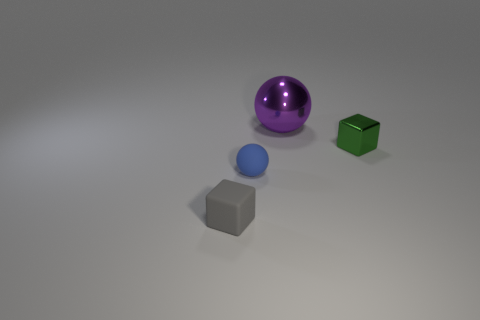What is the color of the tiny rubber thing left of the tiny rubber object to the right of the cube that is to the left of the blue sphere?
Your answer should be very brief. Gray. Is there any other thing that has the same material as the purple ball?
Provide a succinct answer. Yes. What is the size of the purple metallic object that is the same shape as the small blue thing?
Give a very brief answer. Large. Is the number of green objects that are to the left of the big purple shiny object less than the number of tiny cubes on the left side of the metal block?
Give a very brief answer. Yes. There is a thing that is both to the right of the blue sphere and in front of the big thing; what shape is it?
Your answer should be compact. Cube. The green thing that is made of the same material as the big purple thing is what size?
Provide a succinct answer. Small. There is a small matte sphere; is it the same color as the block that is in front of the green metal thing?
Offer a terse response. No. There is a tiny thing that is to the right of the gray object and left of the large shiny object; what material is it?
Offer a terse response. Rubber. There is a metal thing that is in front of the big purple metal ball; is its shape the same as the large purple shiny object that is to the right of the tiny matte cube?
Make the answer very short. No. Are any tiny red rubber cylinders visible?
Ensure brevity in your answer.  No. 